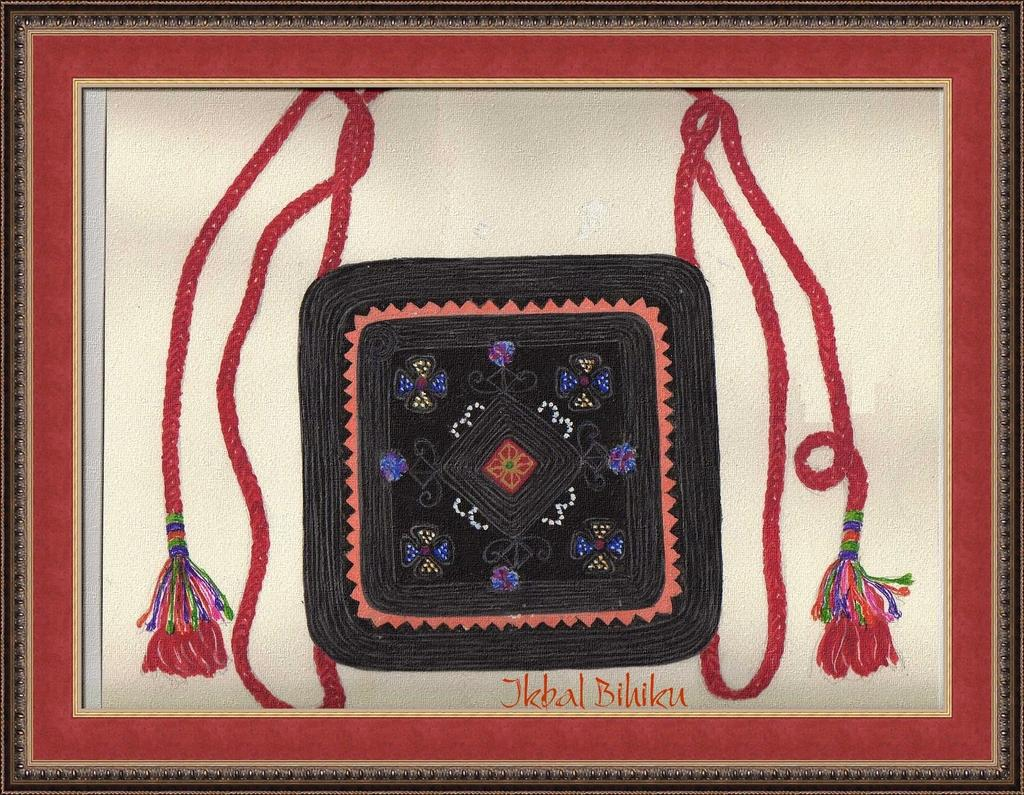<image>
Give a short and clear explanation of the subsequent image. A framed piece of art that is signed in orange letters by the artist, Jkbal Bihiku. 